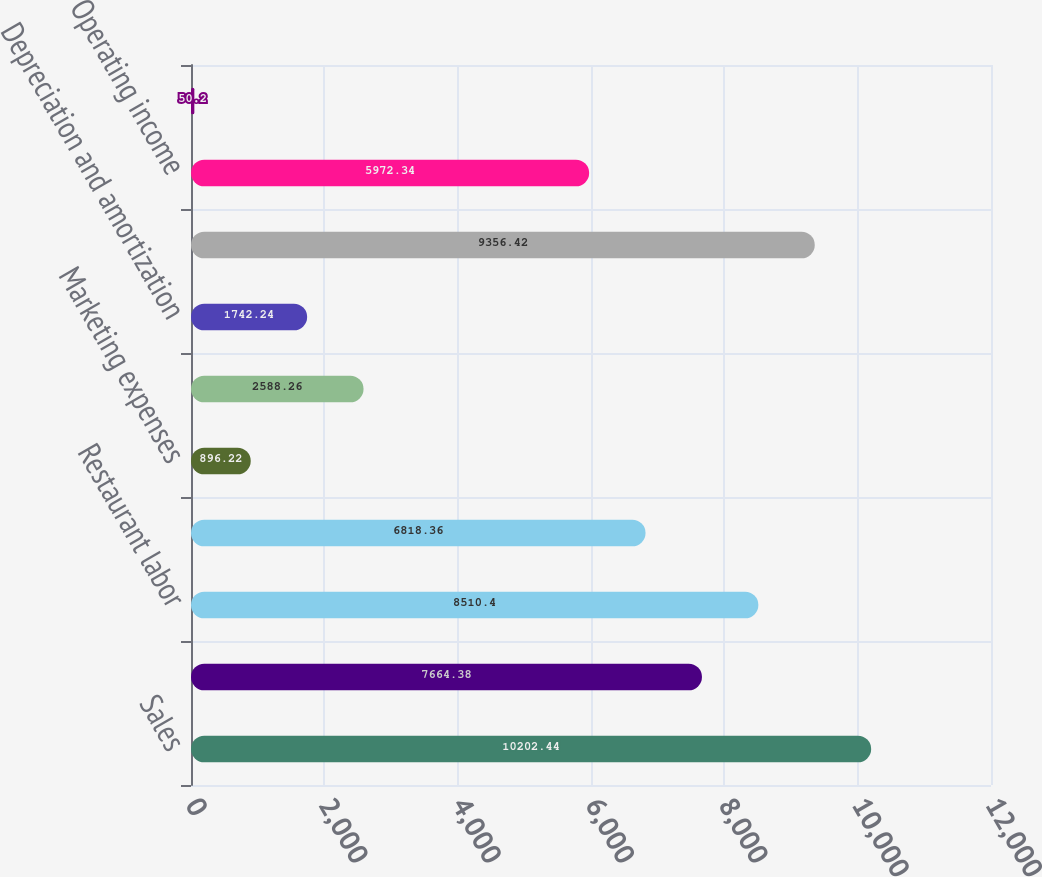<chart> <loc_0><loc_0><loc_500><loc_500><bar_chart><fcel>Sales<fcel>Food and beverage<fcel>Restaurant labor<fcel>Restaurant expenses<fcel>Marketing expenses<fcel>General and administrative<fcel>Depreciation and amortization<fcel>Total operating costs and<fcel>Operating income<fcel>Interest net<nl><fcel>10202.4<fcel>7664.38<fcel>8510.4<fcel>6818.36<fcel>896.22<fcel>2588.26<fcel>1742.24<fcel>9356.42<fcel>5972.34<fcel>50.2<nl></chart> 